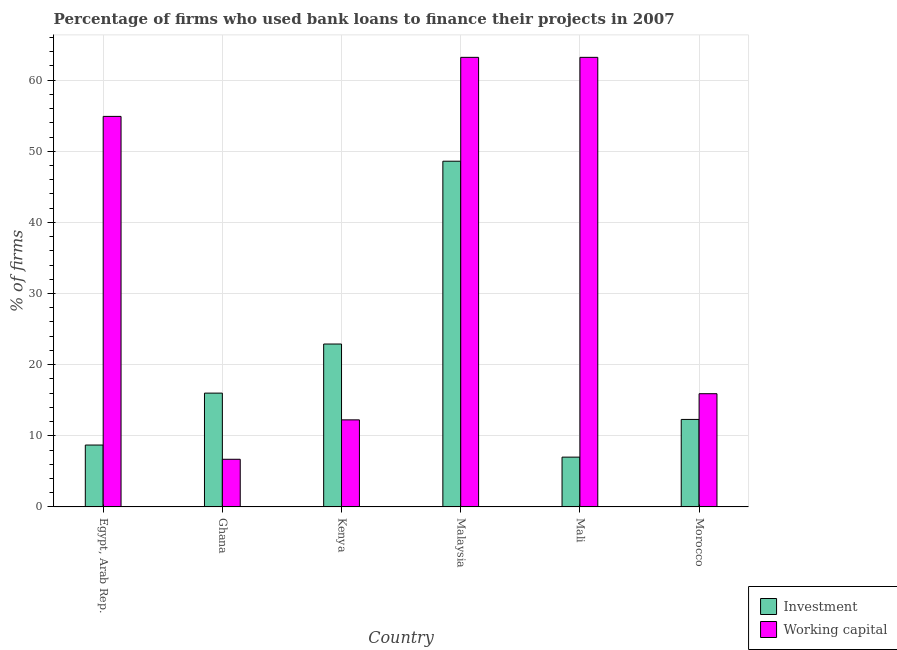How many different coloured bars are there?
Offer a terse response. 2. Are the number of bars per tick equal to the number of legend labels?
Provide a succinct answer. Yes. Are the number of bars on each tick of the X-axis equal?
Ensure brevity in your answer.  Yes. What is the label of the 6th group of bars from the left?
Your response must be concise. Morocco. In how many cases, is the number of bars for a given country not equal to the number of legend labels?
Your answer should be compact. 0. What is the percentage of firms using banks to finance working capital in Ghana?
Make the answer very short. 6.7. Across all countries, what is the maximum percentage of firms using banks to finance investment?
Offer a terse response. 48.6. In which country was the percentage of firms using banks to finance investment maximum?
Offer a very short reply. Malaysia. What is the total percentage of firms using banks to finance working capital in the graph?
Your answer should be very brief. 216.16. What is the difference between the percentage of firms using banks to finance investment in Egypt, Arab Rep. and that in Morocco?
Keep it short and to the point. -3.6. What is the difference between the percentage of firms using banks to finance working capital in Mali and the percentage of firms using banks to finance investment in Egypt, Arab Rep.?
Give a very brief answer. 54.5. What is the average percentage of firms using banks to finance working capital per country?
Provide a short and direct response. 36.03. What is the difference between the percentage of firms using banks to finance investment and percentage of firms using banks to finance working capital in Kenya?
Provide a short and direct response. 10.66. In how many countries, is the percentage of firms using banks to finance working capital greater than 48 %?
Keep it short and to the point. 3. What is the ratio of the percentage of firms using banks to finance investment in Egypt, Arab Rep. to that in Morocco?
Offer a terse response. 0.71. Is the difference between the percentage of firms using banks to finance investment in Ghana and Morocco greater than the difference between the percentage of firms using banks to finance working capital in Ghana and Morocco?
Give a very brief answer. Yes. What is the difference between the highest and the second highest percentage of firms using banks to finance investment?
Your answer should be compact. 25.7. What is the difference between the highest and the lowest percentage of firms using banks to finance investment?
Keep it short and to the point. 41.6. In how many countries, is the percentage of firms using banks to finance investment greater than the average percentage of firms using banks to finance investment taken over all countries?
Ensure brevity in your answer.  2. What does the 2nd bar from the left in Mali represents?
Provide a short and direct response. Working capital. What does the 1st bar from the right in Mali represents?
Your answer should be very brief. Working capital. How many bars are there?
Your response must be concise. 12. Are all the bars in the graph horizontal?
Your answer should be very brief. No. What is the difference between two consecutive major ticks on the Y-axis?
Your response must be concise. 10. Does the graph contain any zero values?
Your answer should be compact. No. How are the legend labels stacked?
Make the answer very short. Vertical. What is the title of the graph?
Your answer should be very brief. Percentage of firms who used bank loans to finance their projects in 2007. What is the label or title of the Y-axis?
Offer a terse response. % of firms. What is the % of firms of Investment in Egypt, Arab Rep.?
Offer a terse response. 8.7. What is the % of firms in Working capital in Egypt, Arab Rep.?
Provide a short and direct response. 54.9. What is the % of firms in Working capital in Ghana?
Your response must be concise. 6.7. What is the % of firms of Investment in Kenya?
Your answer should be compact. 22.9. What is the % of firms in Working capital in Kenya?
Keep it short and to the point. 12.24. What is the % of firms in Investment in Malaysia?
Offer a terse response. 48.6. What is the % of firms of Working capital in Malaysia?
Ensure brevity in your answer.  63.2. What is the % of firms of Working capital in Mali?
Provide a succinct answer. 63.2. What is the % of firms in Working capital in Morocco?
Provide a succinct answer. 15.92. Across all countries, what is the maximum % of firms in Investment?
Offer a very short reply. 48.6. Across all countries, what is the maximum % of firms in Working capital?
Give a very brief answer. 63.2. Across all countries, what is the minimum % of firms of Working capital?
Make the answer very short. 6.7. What is the total % of firms of Investment in the graph?
Provide a succinct answer. 115.5. What is the total % of firms in Working capital in the graph?
Your answer should be very brief. 216.16. What is the difference between the % of firms of Investment in Egypt, Arab Rep. and that in Ghana?
Your answer should be compact. -7.3. What is the difference between the % of firms in Working capital in Egypt, Arab Rep. and that in Ghana?
Your answer should be very brief. 48.2. What is the difference between the % of firms of Investment in Egypt, Arab Rep. and that in Kenya?
Ensure brevity in your answer.  -14.2. What is the difference between the % of firms of Working capital in Egypt, Arab Rep. and that in Kenya?
Keep it short and to the point. 42.66. What is the difference between the % of firms of Investment in Egypt, Arab Rep. and that in Malaysia?
Provide a succinct answer. -39.9. What is the difference between the % of firms of Working capital in Egypt, Arab Rep. and that in Malaysia?
Give a very brief answer. -8.3. What is the difference between the % of firms in Working capital in Egypt, Arab Rep. and that in Mali?
Your answer should be very brief. -8.3. What is the difference between the % of firms of Investment in Egypt, Arab Rep. and that in Morocco?
Offer a terse response. -3.6. What is the difference between the % of firms in Working capital in Egypt, Arab Rep. and that in Morocco?
Offer a very short reply. 38.98. What is the difference between the % of firms of Working capital in Ghana and that in Kenya?
Keep it short and to the point. -5.54. What is the difference between the % of firms of Investment in Ghana and that in Malaysia?
Keep it short and to the point. -32.6. What is the difference between the % of firms of Working capital in Ghana and that in Malaysia?
Make the answer very short. -56.5. What is the difference between the % of firms in Investment in Ghana and that in Mali?
Ensure brevity in your answer.  9. What is the difference between the % of firms in Working capital in Ghana and that in Mali?
Provide a succinct answer. -56.5. What is the difference between the % of firms in Investment in Ghana and that in Morocco?
Provide a short and direct response. 3.7. What is the difference between the % of firms in Working capital in Ghana and that in Morocco?
Give a very brief answer. -9.22. What is the difference between the % of firms in Investment in Kenya and that in Malaysia?
Provide a succinct answer. -25.7. What is the difference between the % of firms of Working capital in Kenya and that in Malaysia?
Provide a succinct answer. -50.96. What is the difference between the % of firms of Investment in Kenya and that in Mali?
Make the answer very short. 15.9. What is the difference between the % of firms of Working capital in Kenya and that in Mali?
Make the answer very short. -50.96. What is the difference between the % of firms in Working capital in Kenya and that in Morocco?
Keep it short and to the point. -3.68. What is the difference between the % of firms of Investment in Malaysia and that in Mali?
Provide a short and direct response. 41.6. What is the difference between the % of firms in Working capital in Malaysia and that in Mali?
Keep it short and to the point. 0. What is the difference between the % of firms of Investment in Malaysia and that in Morocco?
Offer a terse response. 36.3. What is the difference between the % of firms of Working capital in Malaysia and that in Morocco?
Your answer should be compact. 47.28. What is the difference between the % of firms of Investment in Mali and that in Morocco?
Offer a very short reply. -5.3. What is the difference between the % of firms of Working capital in Mali and that in Morocco?
Your answer should be very brief. 47.28. What is the difference between the % of firms of Investment in Egypt, Arab Rep. and the % of firms of Working capital in Kenya?
Provide a succinct answer. -3.54. What is the difference between the % of firms of Investment in Egypt, Arab Rep. and the % of firms of Working capital in Malaysia?
Offer a terse response. -54.5. What is the difference between the % of firms in Investment in Egypt, Arab Rep. and the % of firms in Working capital in Mali?
Provide a succinct answer. -54.5. What is the difference between the % of firms in Investment in Egypt, Arab Rep. and the % of firms in Working capital in Morocco?
Offer a very short reply. -7.22. What is the difference between the % of firms of Investment in Ghana and the % of firms of Working capital in Kenya?
Offer a terse response. 3.76. What is the difference between the % of firms in Investment in Ghana and the % of firms in Working capital in Malaysia?
Offer a terse response. -47.2. What is the difference between the % of firms in Investment in Ghana and the % of firms in Working capital in Mali?
Your answer should be very brief. -47.2. What is the difference between the % of firms in Investment in Ghana and the % of firms in Working capital in Morocco?
Offer a terse response. 0.08. What is the difference between the % of firms of Investment in Kenya and the % of firms of Working capital in Malaysia?
Offer a terse response. -40.3. What is the difference between the % of firms of Investment in Kenya and the % of firms of Working capital in Mali?
Make the answer very short. -40.3. What is the difference between the % of firms in Investment in Kenya and the % of firms in Working capital in Morocco?
Ensure brevity in your answer.  6.98. What is the difference between the % of firms of Investment in Malaysia and the % of firms of Working capital in Mali?
Provide a short and direct response. -14.6. What is the difference between the % of firms of Investment in Malaysia and the % of firms of Working capital in Morocco?
Give a very brief answer. 32.68. What is the difference between the % of firms in Investment in Mali and the % of firms in Working capital in Morocco?
Keep it short and to the point. -8.92. What is the average % of firms of Investment per country?
Offer a very short reply. 19.25. What is the average % of firms in Working capital per country?
Your response must be concise. 36.03. What is the difference between the % of firms of Investment and % of firms of Working capital in Egypt, Arab Rep.?
Offer a very short reply. -46.2. What is the difference between the % of firms of Investment and % of firms of Working capital in Ghana?
Keep it short and to the point. 9.3. What is the difference between the % of firms of Investment and % of firms of Working capital in Kenya?
Give a very brief answer. 10.66. What is the difference between the % of firms of Investment and % of firms of Working capital in Malaysia?
Keep it short and to the point. -14.6. What is the difference between the % of firms of Investment and % of firms of Working capital in Mali?
Ensure brevity in your answer.  -56.2. What is the difference between the % of firms in Investment and % of firms in Working capital in Morocco?
Give a very brief answer. -3.62. What is the ratio of the % of firms in Investment in Egypt, Arab Rep. to that in Ghana?
Make the answer very short. 0.54. What is the ratio of the % of firms in Working capital in Egypt, Arab Rep. to that in Ghana?
Your answer should be very brief. 8.19. What is the ratio of the % of firms in Investment in Egypt, Arab Rep. to that in Kenya?
Your answer should be compact. 0.38. What is the ratio of the % of firms in Working capital in Egypt, Arab Rep. to that in Kenya?
Offer a very short reply. 4.49. What is the ratio of the % of firms in Investment in Egypt, Arab Rep. to that in Malaysia?
Offer a very short reply. 0.18. What is the ratio of the % of firms in Working capital in Egypt, Arab Rep. to that in Malaysia?
Ensure brevity in your answer.  0.87. What is the ratio of the % of firms in Investment in Egypt, Arab Rep. to that in Mali?
Your response must be concise. 1.24. What is the ratio of the % of firms in Working capital in Egypt, Arab Rep. to that in Mali?
Provide a succinct answer. 0.87. What is the ratio of the % of firms of Investment in Egypt, Arab Rep. to that in Morocco?
Give a very brief answer. 0.71. What is the ratio of the % of firms of Working capital in Egypt, Arab Rep. to that in Morocco?
Offer a very short reply. 3.45. What is the ratio of the % of firms of Investment in Ghana to that in Kenya?
Your answer should be very brief. 0.7. What is the ratio of the % of firms in Working capital in Ghana to that in Kenya?
Give a very brief answer. 0.55. What is the ratio of the % of firms in Investment in Ghana to that in Malaysia?
Ensure brevity in your answer.  0.33. What is the ratio of the % of firms in Working capital in Ghana to that in Malaysia?
Provide a succinct answer. 0.11. What is the ratio of the % of firms of Investment in Ghana to that in Mali?
Keep it short and to the point. 2.29. What is the ratio of the % of firms of Working capital in Ghana to that in Mali?
Your answer should be compact. 0.11. What is the ratio of the % of firms in Investment in Ghana to that in Morocco?
Offer a terse response. 1.3. What is the ratio of the % of firms of Working capital in Ghana to that in Morocco?
Your answer should be compact. 0.42. What is the ratio of the % of firms in Investment in Kenya to that in Malaysia?
Offer a terse response. 0.47. What is the ratio of the % of firms of Working capital in Kenya to that in Malaysia?
Your response must be concise. 0.19. What is the ratio of the % of firms in Investment in Kenya to that in Mali?
Your response must be concise. 3.27. What is the ratio of the % of firms in Working capital in Kenya to that in Mali?
Offer a terse response. 0.19. What is the ratio of the % of firms of Investment in Kenya to that in Morocco?
Your response must be concise. 1.86. What is the ratio of the % of firms of Working capital in Kenya to that in Morocco?
Offer a terse response. 0.77. What is the ratio of the % of firms in Investment in Malaysia to that in Mali?
Give a very brief answer. 6.94. What is the ratio of the % of firms of Working capital in Malaysia to that in Mali?
Provide a succinct answer. 1. What is the ratio of the % of firms of Investment in Malaysia to that in Morocco?
Your response must be concise. 3.95. What is the ratio of the % of firms of Working capital in Malaysia to that in Morocco?
Provide a succinct answer. 3.97. What is the ratio of the % of firms of Investment in Mali to that in Morocco?
Your response must be concise. 0.57. What is the ratio of the % of firms of Working capital in Mali to that in Morocco?
Offer a very short reply. 3.97. What is the difference between the highest and the second highest % of firms of Investment?
Provide a short and direct response. 25.7. What is the difference between the highest and the lowest % of firms of Investment?
Your answer should be compact. 41.6. What is the difference between the highest and the lowest % of firms of Working capital?
Your answer should be very brief. 56.5. 